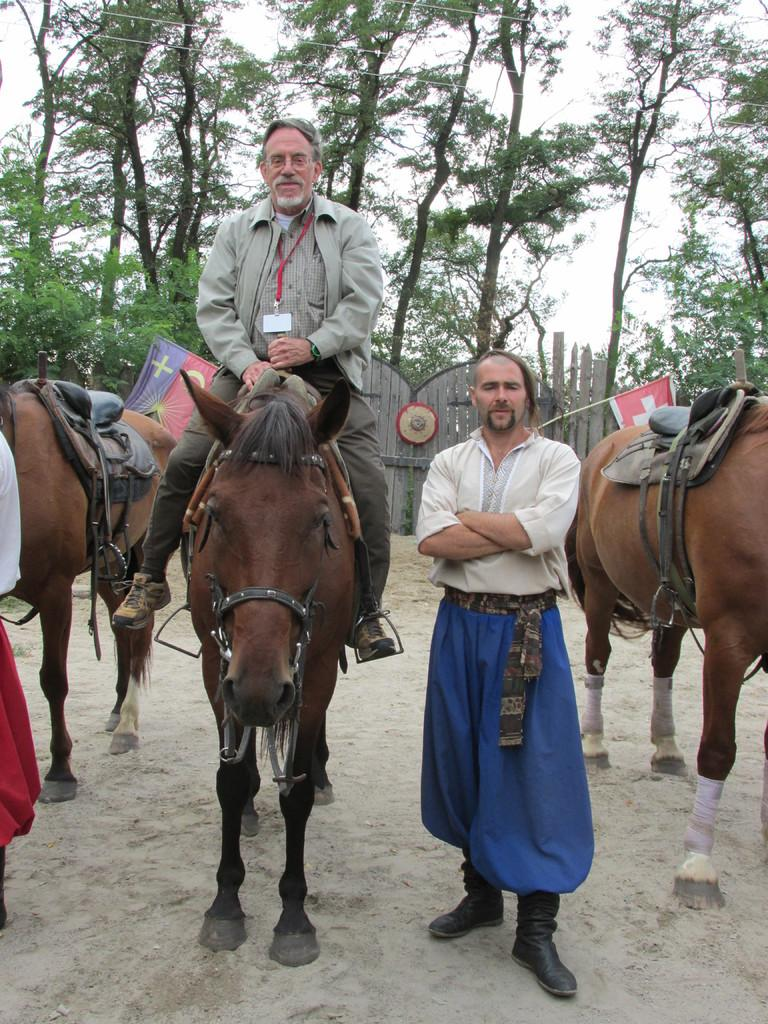What is the person sitting on in the image? The person is sitting on an animal in the image. Who is standing beside the sitting person? There is a person standing beside the sitting person. What type of natural environment can be seen in the image? Trees are visible in the image. What other living creatures are present in the image? There are animals present in the image. What additional objects can be seen in the image? There are flags visible in the image. What is visible in the background of the image? The sky is visible in the image. What type of church can be seen in the image? There is no church present in the image. Who is the creator of the animals in the image? The image does not provide information about the creator of the animals. How old is the baby in the image? There is no baby present in the image. 